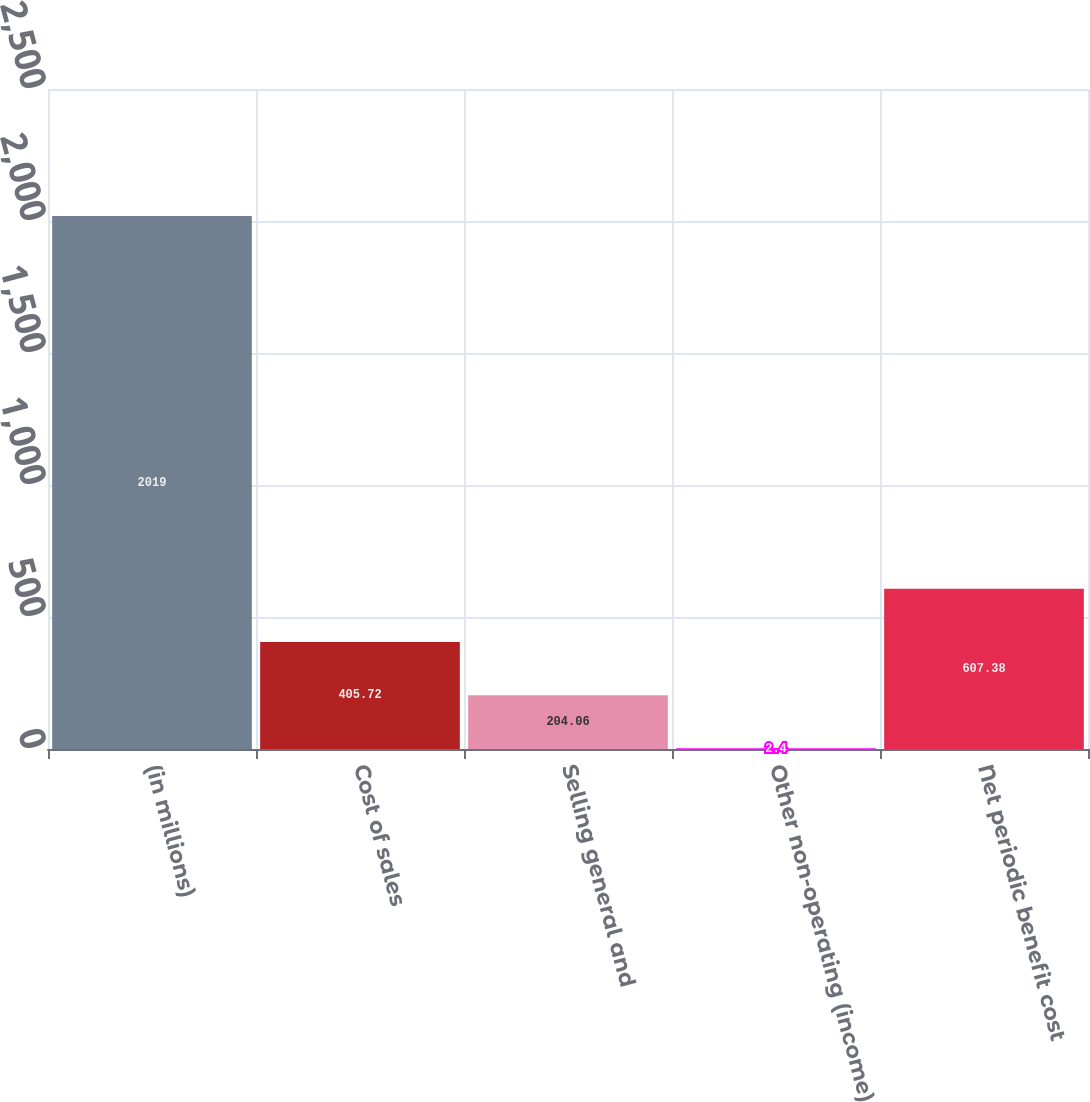Convert chart. <chart><loc_0><loc_0><loc_500><loc_500><bar_chart><fcel>(in millions)<fcel>Cost of sales<fcel>Selling general and<fcel>Other non-operating (income)<fcel>Net periodic benefit cost<nl><fcel>2019<fcel>405.72<fcel>204.06<fcel>2.4<fcel>607.38<nl></chart> 